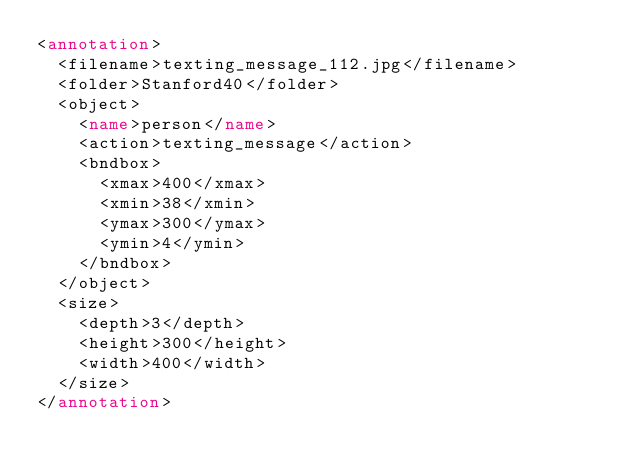<code> <loc_0><loc_0><loc_500><loc_500><_XML_><annotation>
  <filename>texting_message_112.jpg</filename>
  <folder>Stanford40</folder>
  <object>
    <name>person</name>
    <action>texting_message</action>
    <bndbox>
      <xmax>400</xmax>
      <xmin>38</xmin>
      <ymax>300</ymax>
      <ymin>4</ymin>
    </bndbox>
  </object>
  <size>
    <depth>3</depth>
    <height>300</height>
    <width>400</width>
  </size>
</annotation>
</code> 